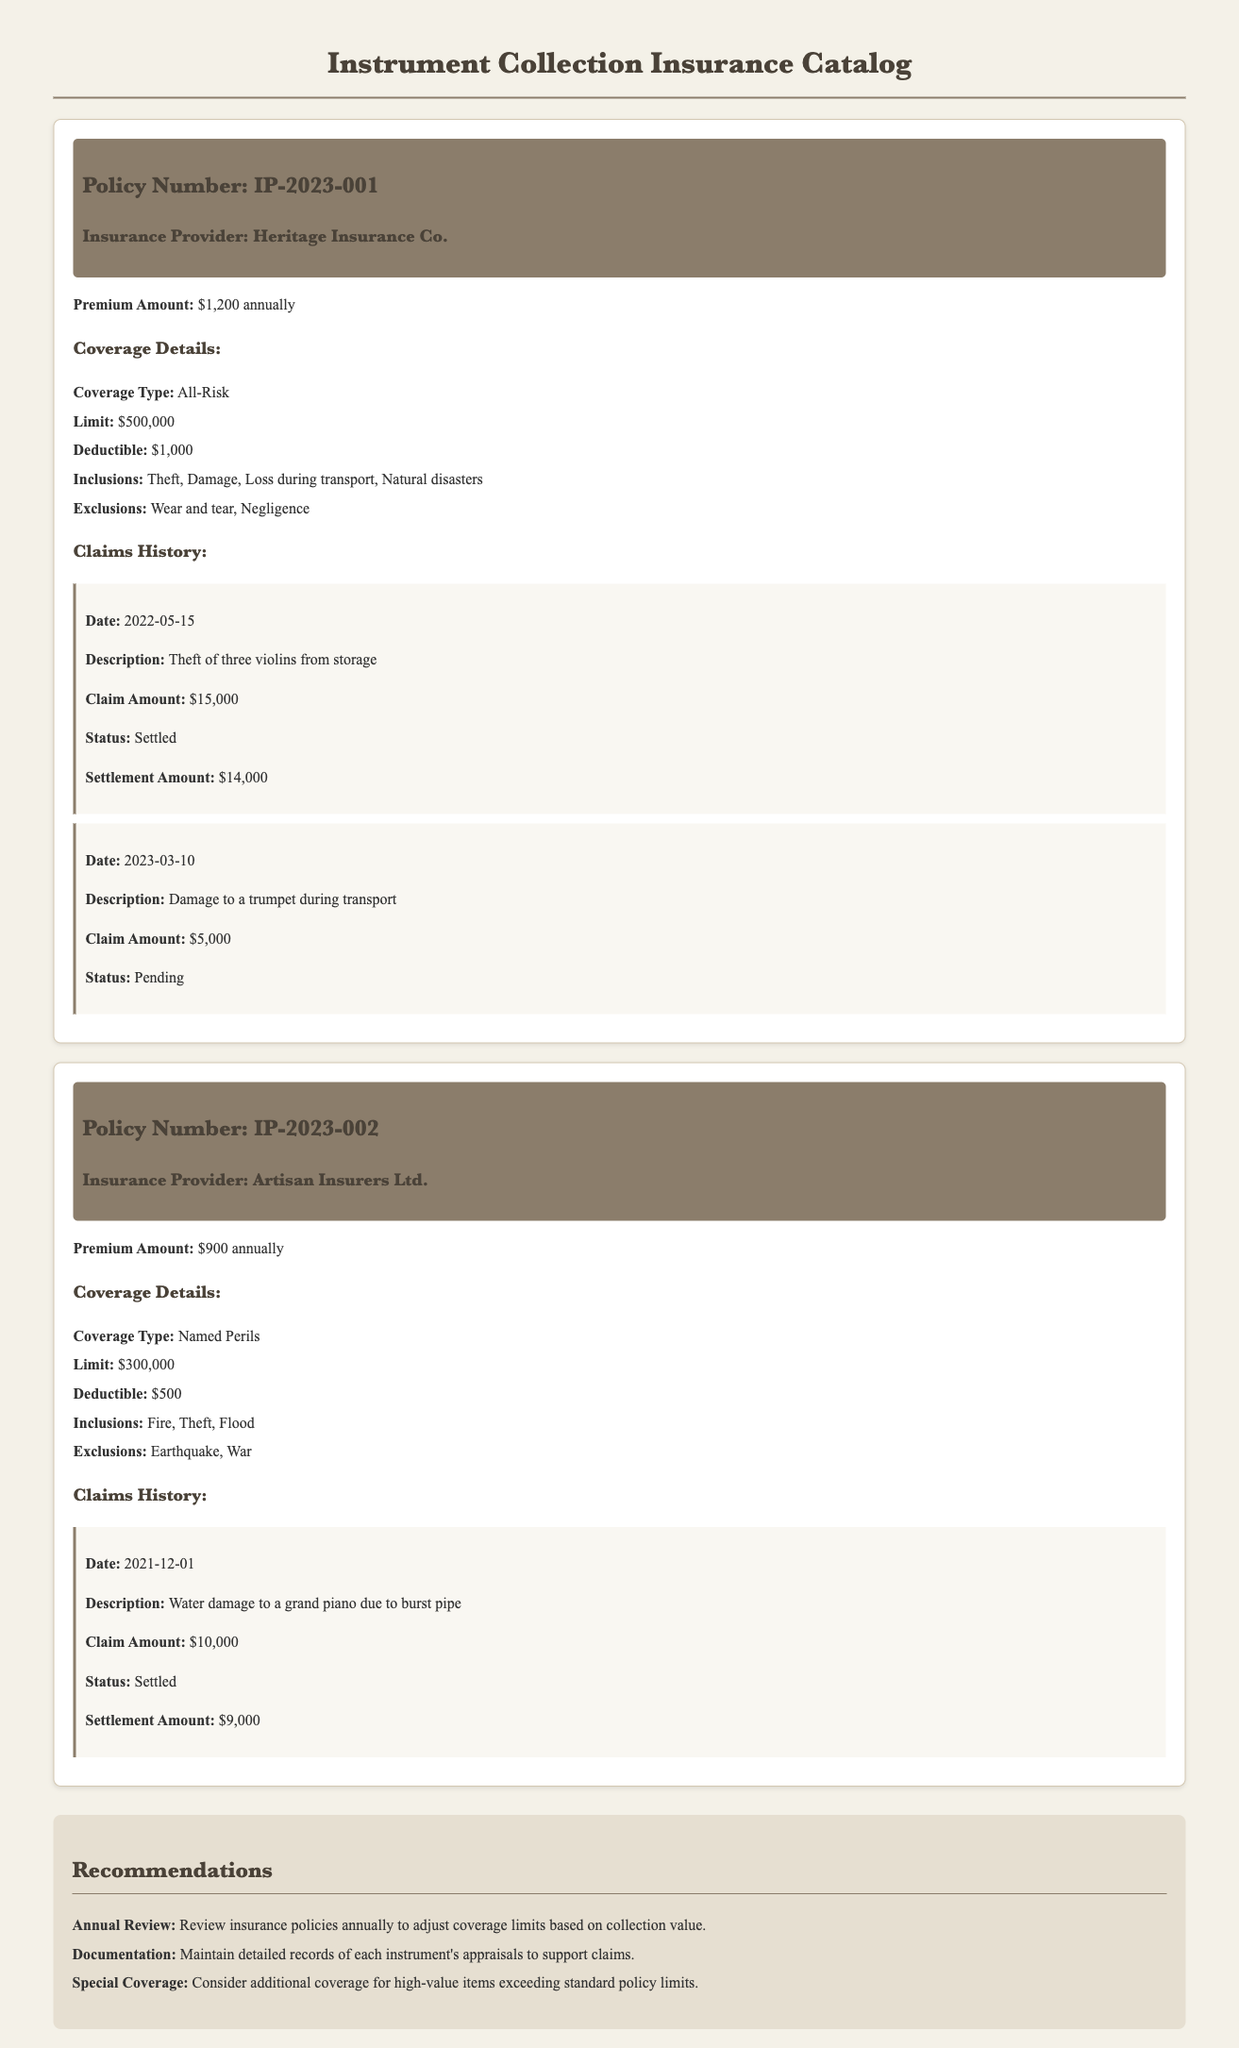What is the premium amount for Policy Number IP-2023-001? The premium amount for this policy is specifically stated in the document as $1,200 annually.
Answer: $1,200 annually What is the total limit of coverage for Policy Number IP-2023-002? The document states that the limit for this policy is $300,000, which directly answers the question.
Answer: $300,000 What is the deductible for the all-risk coverage policy? The deductible for Policy Number IP-2023-001 is explicitly mentioned as $1,000 in the coverage details.
Answer: $1,000 How many claims have been settled for Policy Number IP-2023-001? The claims history section indicates one claim was settled for Policy Number IP-2023-001.
Answer: One claim What is the status of the claim filed on 2023-03-10? The status of this claim is indicated in the document as "Pending."
Answer: Pending What are the exclusions for Policy Number IP-2023-002? The document lists the exclusions as Earthquake and War, which answers the question directly.
Answer: Earthquake, War What type of coverage does Policy Number IP-2023-001 offer? The specific type of coverage is mentioned as All-Risk in the coverage details for this policy.
Answer: All-Risk What was the settlement amount for the water damage claim on 2021-12-01? The settlement amount for this claim is provided in the document as $9,000.
Answer: $9,000 What is a recommended action regarding insurance policies? The document recommends maintaining detailed records of appraisal for supporting claims.
Answer: Maintain detailed records of appraisals 